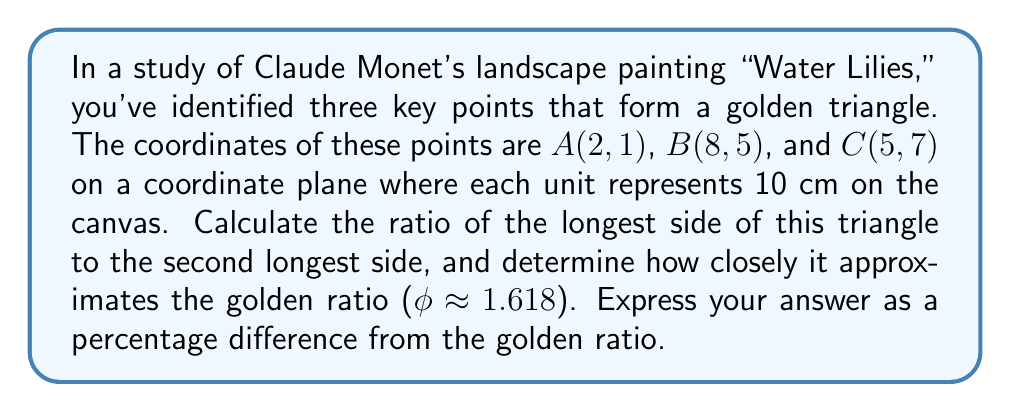Give your solution to this math problem. To solve this problem, we'll follow these steps:

1) First, calculate the lengths of all sides of the triangle using the distance formula:
   $$d = \sqrt{(x_2-x_1)^2 + (y_2-y_1)^2}$$

   AB: $$\sqrt{(8-2)^2 + (5-1)^2} = \sqrt{36 + 16} = \sqrt{52} \approx 7.21$$
   BC: $$\sqrt{(5-8)^2 + (7-5)^2} = \sqrt{9 + 4} = \sqrt{13} \approx 3.61$$
   AC: $$\sqrt{(5-2)^2 + (7-1)^2} = \sqrt{9 + 36} = \sqrt{45} \approx 6.71$$

2) Identify the longest and second longest sides:
   Longest: AB ≈ 7.21
   Second longest: AC ≈ 6.71

3) Calculate the ratio of the longest to the second longest side:
   $$\frac{AB}{AC} = \frac{7.21}{6.71} \approx 1.0746$$

4) Calculate the percentage difference from the golden ratio:
   $$\text{Percentage difference} = \left|\frac{\text{Calculated ratio} - \text{Golden ratio}}{\text{Golden ratio}}\right| \times 100\%$$
   $$= \left|\frac{1.0746 - 1.618}{1.618}\right| \times 100\% \approx 33.58\%$$
Answer: The ratio of the longest side to the second longest side is approximately 1.0746, which differs from the golden ratio by about 33.58%. 